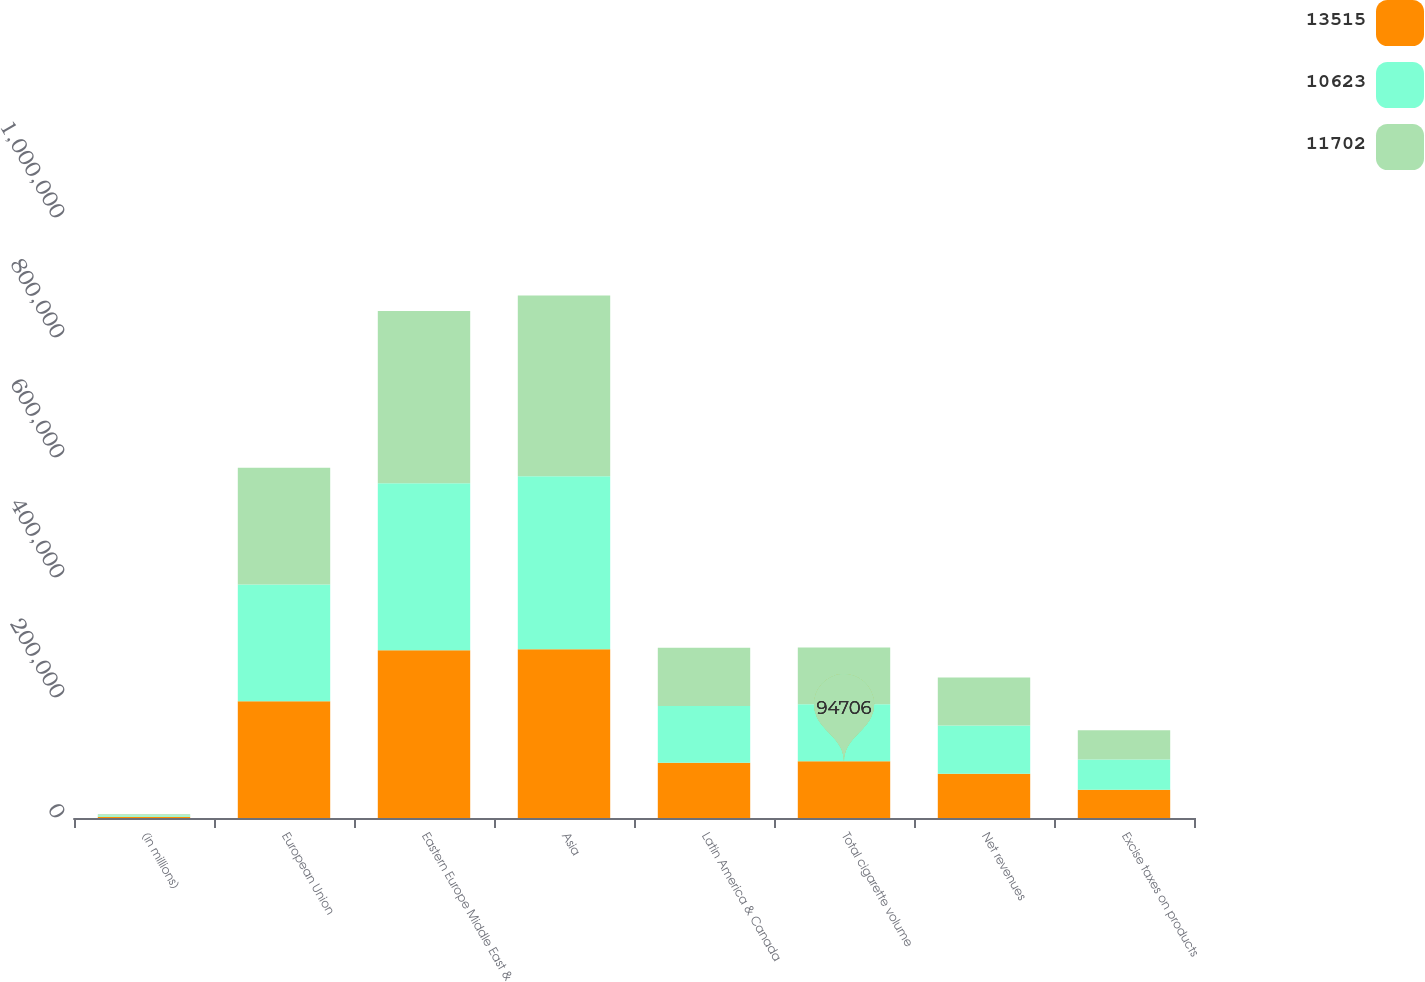Convert chart to OTSL. <chart><loc_0><loc_0><loc_500><loc_500><stacked_bar_chart><ecel><fcel>(in millions)<fcel>European Union<fcel>Eastern Europe Middle East &<fcel>Asia<fcel>Latin America & Canada<fcel>Total cigarette volume<fcel>Net revenues<fcel>Excise taxes on products<nl><fcel>13515<fcel>2015<fcel>194589<fcel>279411<fcel>281350<fcel>91920<fcel>94706<fcel>73908<fcel>47114<nl><fcel>10623<fcel>2014<fcel>194746<fcel>278374<fcel>288128<fcel>94706<fcel>94706<fcel>80106<fcel>50339<nl><fcel>11702<fcel>2013<fcel>194464<fcel>287094<fcel>301324<fcel>97287<fcel>94706<fcel>80029<fcel>48812<nl></chart> 